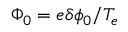Convert formula to latex. <formula><loc_0><loc_0><loc_500><loc_500>\Phi _ { 0 } = e \delta \phi _ { 0 } / T _ { e }</formula> 